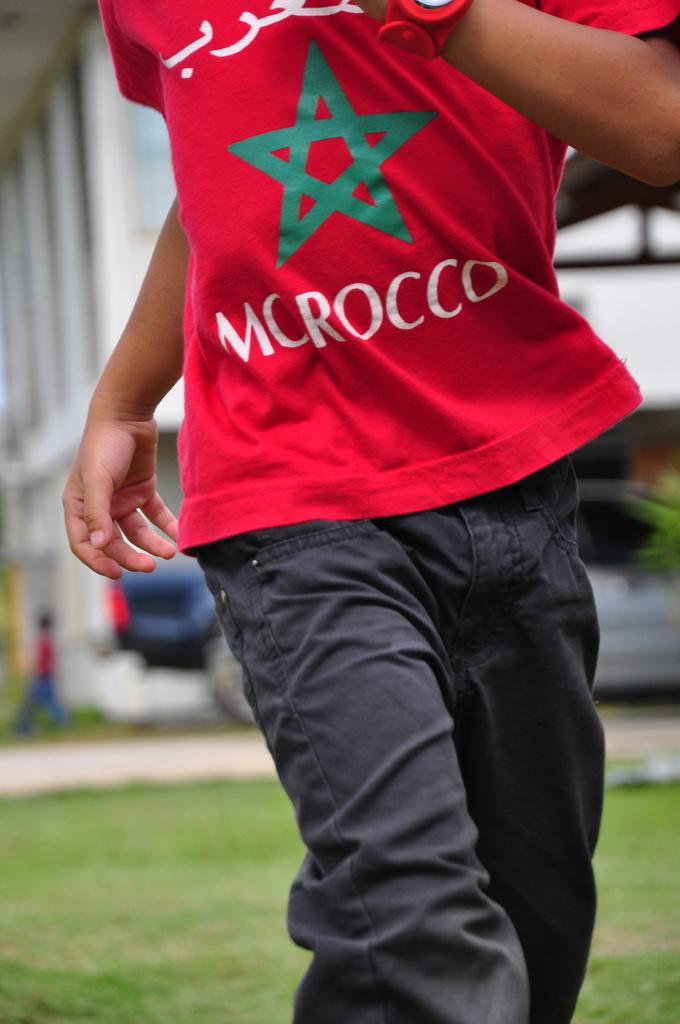What country is under the green star on the shirt?
Ensure brevity in your answer.  Morocco. 